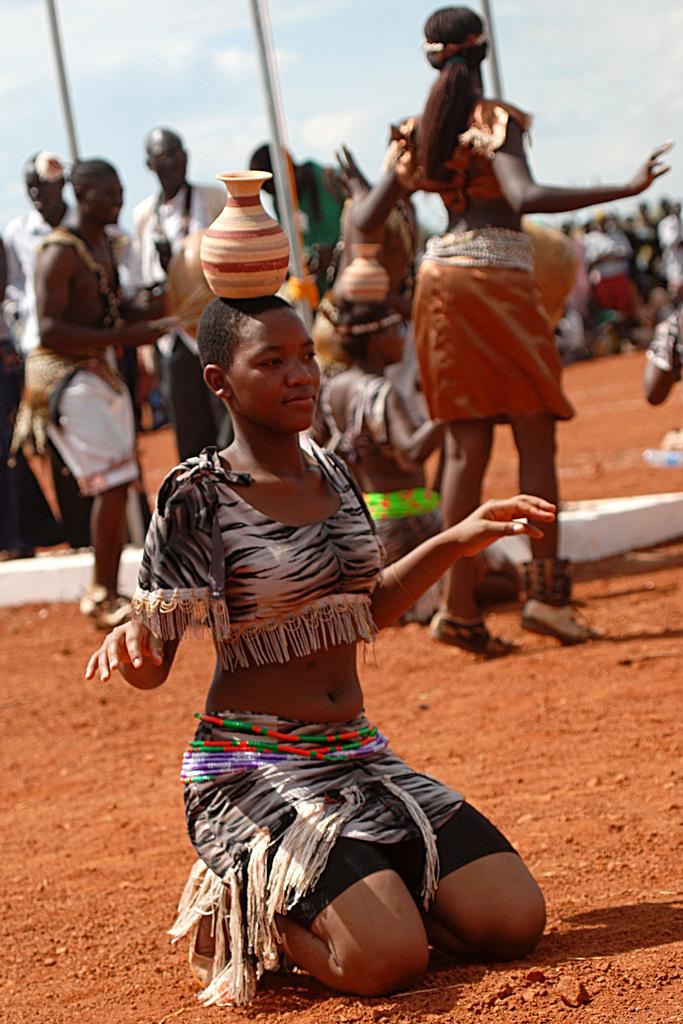How many people are in the image? There are people in the image. What are two people doing in the image? Two people are carrying pots on their heads. What objects can be seen in the image besides the people? There are poles in the image. What is visible in the background of the image? The sky is visible in the image. How many beds are visible in the image? There are no beds present in the image. What type of station is shown in the image? There is no station depicted in the image. 